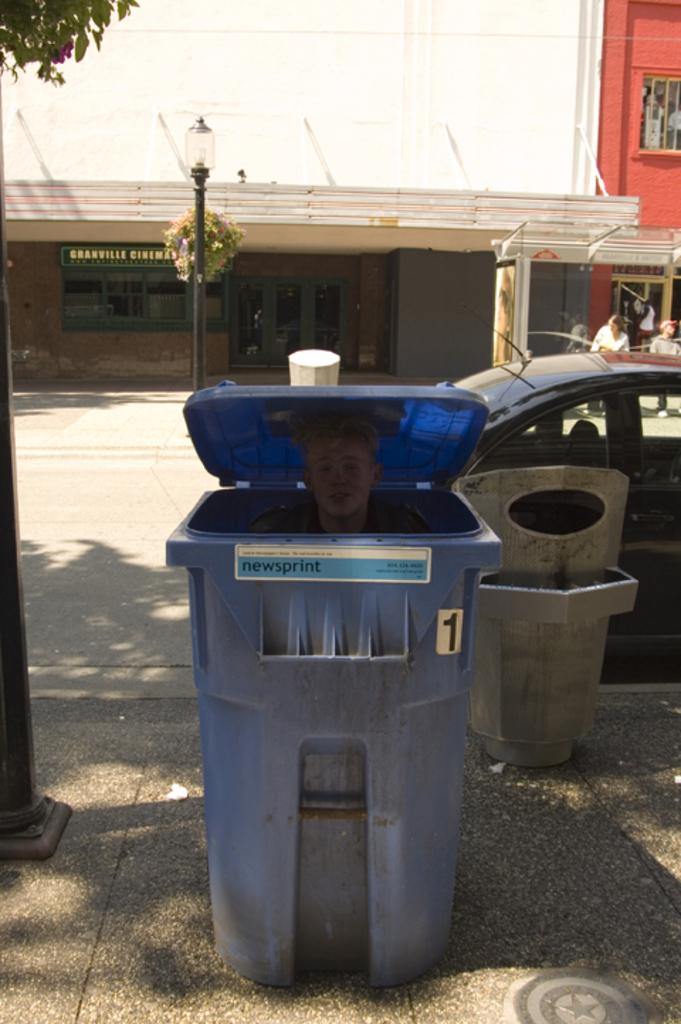Provide a one-sentence caption for the provided image. A person in a blue bin marked 1 that says newsprint. 